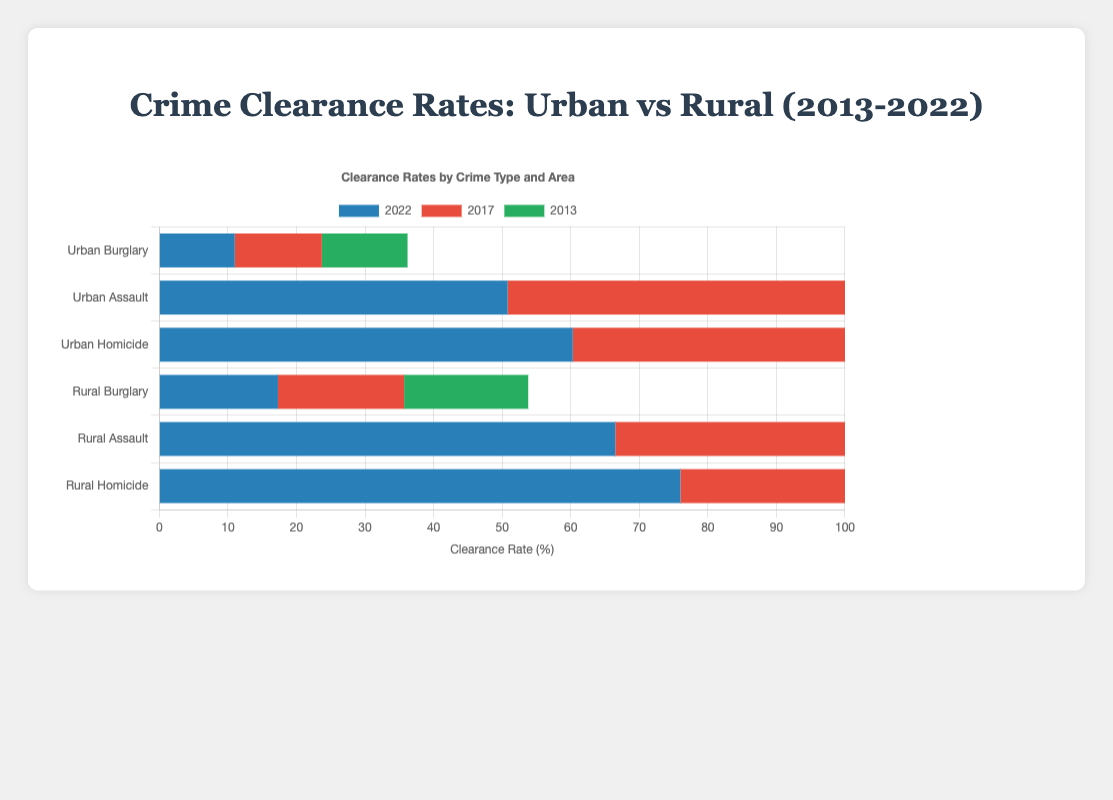How did the theft clearance rate change in urban areas from 2013 to 2022? To determine the change, identify the clearance rates for burglary in 2013 (12.5%) and 2022 (11.0%). Subtract the 2022 value from the 2013 value: 12.5% - 11.0% = 1.5%.
Answer: Decreased by 1.5% Which area had a higher homicide clearance rate in 2013: urban or rural? Compare the homicide clearance rates for 2013: urban is 61.0% and rural is 75.3%. The rural rate is higher.
Answer: Rural What crime type had the smallest decline in clearance rate in rural areas from 2013 to 2022? For each crime in rural areas, calculate the difference between 2013 and 2022 values. Burglary: 18.1 - 17.3 = 0.8, Assault: 65.2 - 66.5 = -1.3 (increase), Homicide: 75.3 - 76.0 = -0.7 (increase). Burglary has the smallest decline.
Answer: Burglary How do the clearance rates for assault in urban areas in 2013 and rural areas in 2022 compare? The urban assault clearance rate in 2013 is 49.1%, and in rural areas in 2022, it is 66.5%. Rural 2022 rate is higher.
Answer: Rural 2022 is higher What was the trend for homicide clearance rates in rural areas over the decade? Observe the homicide clearance rates for rural areas from 2013 (75.3%) to 2022 (76.0%). The rates show a slight increase.
Answer: Increasing What is the combined clearance rate for all urban crime types in 2017? Sum the urban clearance rates in 2017: burglary (12.7%), assault (49.8%), homicide (57.9%). 12.7 + 49.8 + 57.9 = 120.4%.
Answer: 120.4% Which crime type showed a smaller change in clearance rates in urban areas between 2013 and 2022: assault or homicide? Calculate the change for each: Assault: 50.8 - 49.1 = 1.7% increase, Homicide: 60.3 - 61.0 = -0.7% decrease. Assault showed a smaller change.
Answer: Assault What's the difference in clearance rates for burglary between urban and rural areas in 2022? Compare the burglary clearance rates for 2022: urban (11.0%) and rural (17.3%). The difference is 17.3% - 11.0% = 6.3%.
Answer: 6.3% What was the clearance rate for urban assault in 2017? Look at the bar labeled "Urban Assault" for the year 2017, which shows a clearance rate of 49.8%.
Answer: 49.8% What is the overall percentage increase in the rural homicide clearance rate from 2013 to 2022? The rural homicide clearance rate increased from 75.3% in 2013 to 76.0% in 2022. The increase is 76.0 - 75.3 = 0.7%, and the percentage increase is (0.7 / 75.3) * 100 ≈ 0.93%.
Answer: 0.93% 